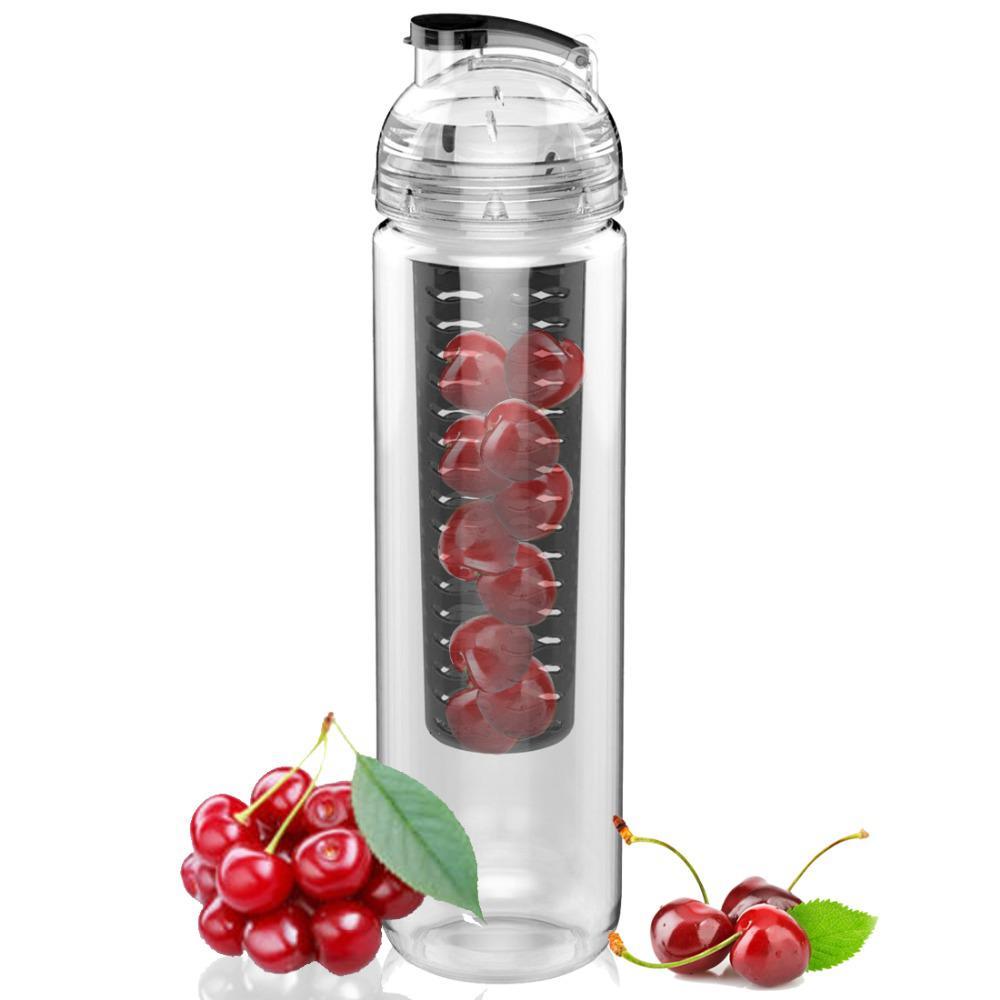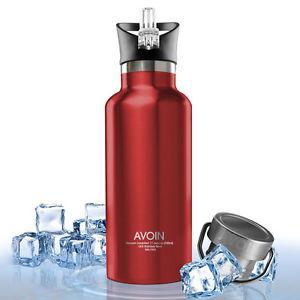The first image is the image on the left, the second image is the image on the right. For the images displayed, is the sentence "At least one of the water bottles has other objects next to it." factually correct? Answer yes or no. Yes. 